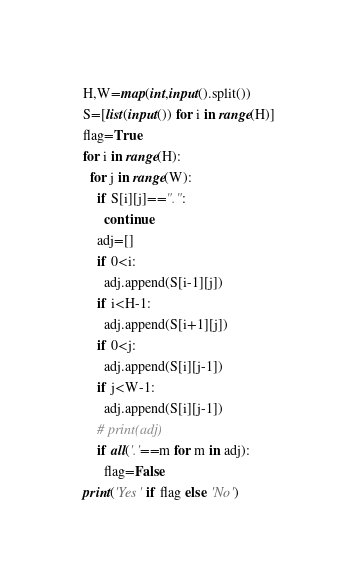Convert code to text. <code><loc_0><loc_0><loc_500><loc_500><_Python_>H,W=map(int,input().split())
S=[list(input()) for i in range(H)]
flag=True
for i in range(H):
  for j in range(W):
    if S[i][j]==".":
      continue
    adj=[]
    if 0<i:
      adj.append(S[i-1][j])
    if i<H-1:
      adj.append(S[i+1][j])
    if 0<j:
      adj.append(S[i][j-1])
    if j<W-1:
      adj.append(S[i][j-1])
    # print(adj)
    if all('.'==m for m in adj):
      flag=False
print('Yes' if flag else 'No')</code> 